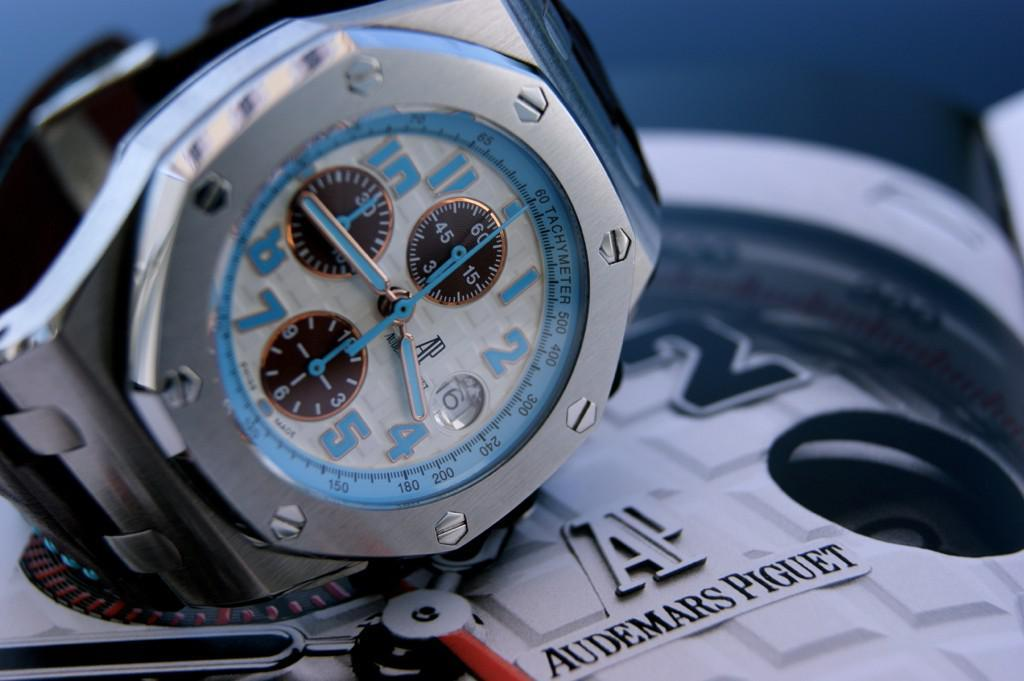<image>
Create a compact narrative representing the image presented. An AP brand watch has blue numbers and blue hands. 